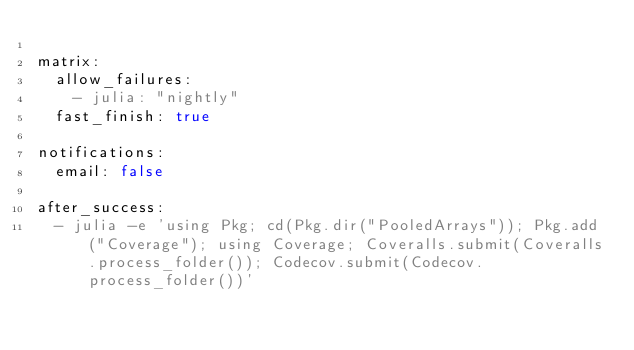<code> <loc_0><loc_0><loc_500><loc_500><_YAML_>
matrix:
  allow_failures:
    - julia: "nightly"
  fast_finish: true

notifications:
  email: false

after_success:
  - julia -e 'using Pkg; cd(Pkg.dir("PooledArrays")); Pkg.add("Coverage"); using Coverage; Coveralls.submit(Coveralls.process_folder()); Codecov.submit(Codecov.process_folder())'
</code> 